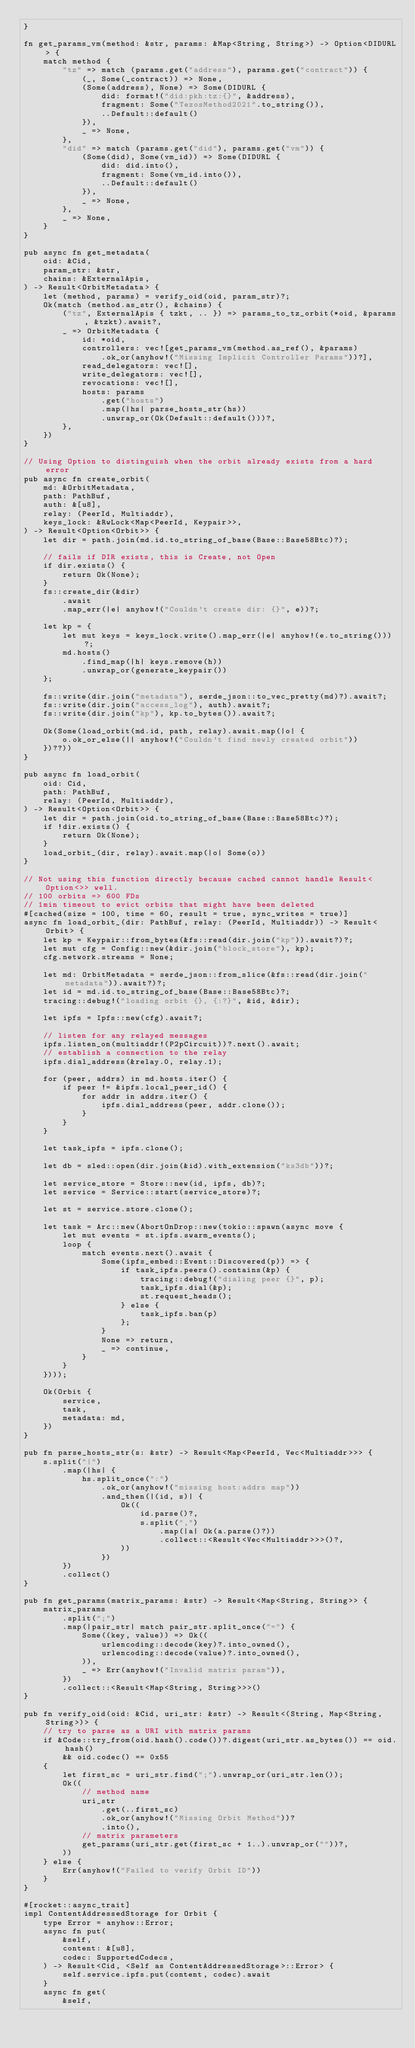Convert code to text. <code><loc_0><loc_0><loc_500><loc_500><_Rust_>}

fn get_params_vm(method: &str, params: &Map<String, String>) -> Option<DIDURL> {
    match method {
        "tz" => match (params.get("address"), params.get("contract")) {
            (_, Some(_contract)) => None,
            (Some(address), None) => Some(DIDURL {
                did: format!("did:pkh:tz:{}", &address),
                fragment: Some("TezosMethod2021".to_string()),
                ..Default::default()
            }),
            _ => None,
        },
        "did" => match (params.get("did"), params.get("vm")) {
            (Some(did), Some(vm_id)) => Some(DIDURL {
                did: did.into(),
                fragment: Some(vm_id.into()),
                ..Default::default()
            }),
            _ => None,
        },
        _ => None,
    }
}

pub async fn get_metadata(
    oid: &Cid,
    param_str: &str,
    chains: &ExternalApis,
) -> Result<OrbitMetadata> {
    let (method, params) = verify_oid(oid, param_str)?;
    Ok(match (method.as_str(), &chains) {
        ("tz", ExternalApis { tzkt, .. }) => params_to_tz_orbit(*oid, &params, &tzkt).await?,
        _ => OrbitMetadata {
            id: *oid,
            controllers: vec![get_params_vm(method.as_ref(), &params)
                .ok_or(anyhow!("Missing Implicit Controller Params"))?],
            read_delegators: vec![],
            write_delegators: vec![],
            revocations: vec![],
            hosts: params
                .get("hosts")
                .map(|hs| parse_hosts_str(hs))
                .unwrap_or(Ok(Default::default()))?,
        },
    })
}

// Using Option to distinguish when the orbit already exists from a hard error
pub async fn create_orbit(
    md: &OrbitMetadata,
    path: PathBuf,
    auth: &[u8],
    relay: (PeerId, Multiaddr),
    keys_lock: &RwLock<Map<PeerId, Keypair>>,
) -> Result<Option<Orbit>> {
    let dir = path.join(md.id.to_string_of_base(Base::Base58Btc)?);

    // fails if DIR exists, this is Create, not Open
    if dir.exists() {
        return Ok(None);
    }
    fs::create_dir(&dir)
        .await
        .map_err(|e| anyhow!("Couldn't create dir: {}", e))?;

    let kp = {
        let mut keys = keys_lock.write().map_err(|e| anyhow!(e.to_string()))?;
        md.hosts()
            .find_map(|h| keys.remove(h))
            .unwrap_or(generate_keypair())
    };

    fs::write(dir.join("metadata"), serde_json::to_vec_pretty(md)?).await?;
    fs::write(dir.join("access_log"), auth).await?;
    fs::write(dir.join("kp"), kp.to_bytes()).await?;

    Ok(Some(load_orbit(md.id, path, relay).await.map(|o| {
        o.ok_or_else(|| anyhow!("Couldn't find newly created orbit"))
    })??))
}

pub async fn load_orbit(
    oid: Cid,
    path: PathBuf,
    relay: (PeerId, Multiaddr),
) -> Result<Option<Orbit>> {
    let dir = path.join(oid.to_string_of_base(Base::Base58Btc)?);
    if !dir.exists() {
        return Ok(None);
    }
    load_orbit_(dir, relay).await.map(|o| Some(o))
}

// Not using this function directly because cached cannot handle Result<Option<>> well.
// 100 orbits => 600 FDs
// 1min timeout to evict orbits that might have been deleted
#[cached(size = 100, time = 60, result = true, sync_writes = true)]
async fn load_orbit_(dir: PathBuf, relay: (PeerId, Multiaddr)) -> Result<Orbit> {
    let kp = Keypair::from_bytes(&fs::read(dir.join("kp")).await?)?;
    let mut cfg = Config::new(&dir.join("block_store"), kp);
    cfg.network.streams = None;

    let md: OrbitMetadata = serde_json::from_slice(&fs::read(dir.join("metadata")).await?)?;
    let id = md.id.to_string_of_base(Base::Base58Btc)?;
    tracing::debug!("loading orbit {}, {:?}", &id, &dir);

    let ipfs = Ipfs::new(cfg).await?;

    // listen for any relayed messages
    ipfs.listen_on(multiaddr!(P2pCircuit))?.next().await;
    // establish a connection to the relay
    ipfs.dial_address(&relay.0, relay.1);

    for (peer, addrs) in md.hosts.iter() {
        if peer != &ipfs.local_peer_id() {
            for addr in addrs.iter() {
                ipfs.dial_address(peer, addr.clone());
            }
        }
    }

    let task_ipfs = ipfs.clone();

    let db = sled::open(dir.join(&id).with_extension("ks3db"))?;

    let service_store = Store::new(id, ipfs, db)?;
    let service = Service::start(service_store)?;

    let st = service.store.clone();

    let task = Arc::new(AbortOnDrop::new(tokio::spawn(async move {
        let mut events = st.ipfs.swarm_events();
        loop {
            match events.next().await {
                Some(ipfs_embed::Event::Discovered(p)) => {
                    if task_ipfs.peers().contains(&p) {
                        tracing::debug!("dialing peer {}", p);
                        task_ipfs.dial(&p);
                        st.request_heads();
                    } else {
                        task_ipfs.ban(p)
                    };
                }
                None => return,
                _ => continue,
            }
        }
    })));

    Ok(Orbit {
        service,
        task,
        metadata: md,
    })
}

pub fn parse_hosts_str(s: &str) -> Result<Map<PeerId, Vec<Multiaddr>>> {
    s.split("|")
        .map(|hs| {
            hs.split_once(":")
                .ok_or(anyhow!("missing host:addrs map"))
                .and_then(|(id, s)| {
                    Ok((
                        id.parse()?,
                        s.split(",")
                            .map(|a| Ok(a.parse()?))
                            .collect::<Result<Vec<Multiaddr>>>()?,
                    ))
                })
        })
        .collect()
}

pub fn get_params(matrix_params: &str) -> Result<Map<String, String>> {
    matrix_params
        .split(";")
        .map(|pair_str| match pair_str.split_once("=") {
            Some((key, value)) => Ok((
                urlencoding::decode(key)?.into_owned(),
                urlencoding::decode(value)?.into_owned(),
            )),
            _ => Err(anyhow!("Invalid matrix param")),
        })
        .collect::<Result<Map<String, String>>>()
}

pub fn verify_oid(oid: &Cid, uri_str: &str) -> Result<(String, Map<String, String>)> {
    // try to parse as a URI with matrix params
    if &Code::try_from(oid.hash().code())?.digest(uri_str.as_bytes()) == oid.hash()
        && oid.codec() == 0x55
    {
        let first_sc = uri_str.find(";").unwrap_or(uri_str.len());
        Ok((
            // method name
            uri_str
                .get(..first_sc)
                .ok_or(anyhow!("Missing Orbit Method"))?
                .into(),
            // matrix parameters
            get_params(uri_str.get(first_sc + 1..).unwrap_or(""))?,
        ))
    } else {
        Err(anyhow!("Failed to verify Orbit ID"))
    }
}

#[rocket::async_trait]
impl ContentAddressedStorage for Orbit {
    type Error = anyhow::Error;
    async fn put(
        &self,
        content: &[u8],
        codec: SupportedCodecs,
    ) -> Result<Cid, <Self as ContentAddressedStorage>::Error> {
        self.service.ipfs.put(content, codec).await
    }
    async fn get(
        &self,</code> 